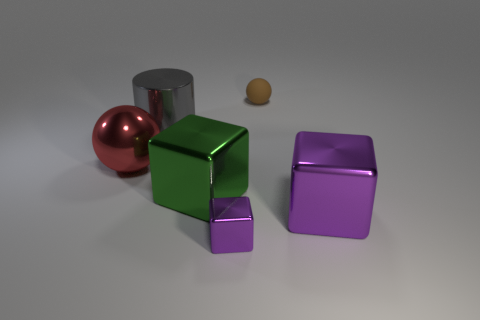How does the lighting in the scene affect the appearance of the objects? The lighting in the scene casts soft shadows and enhances the reflective qualities of the objects, highlighting their textures and materials, such as the sheen on the metallic and rubber surfaces, creating an aesthetically pleasing composition with depth. 